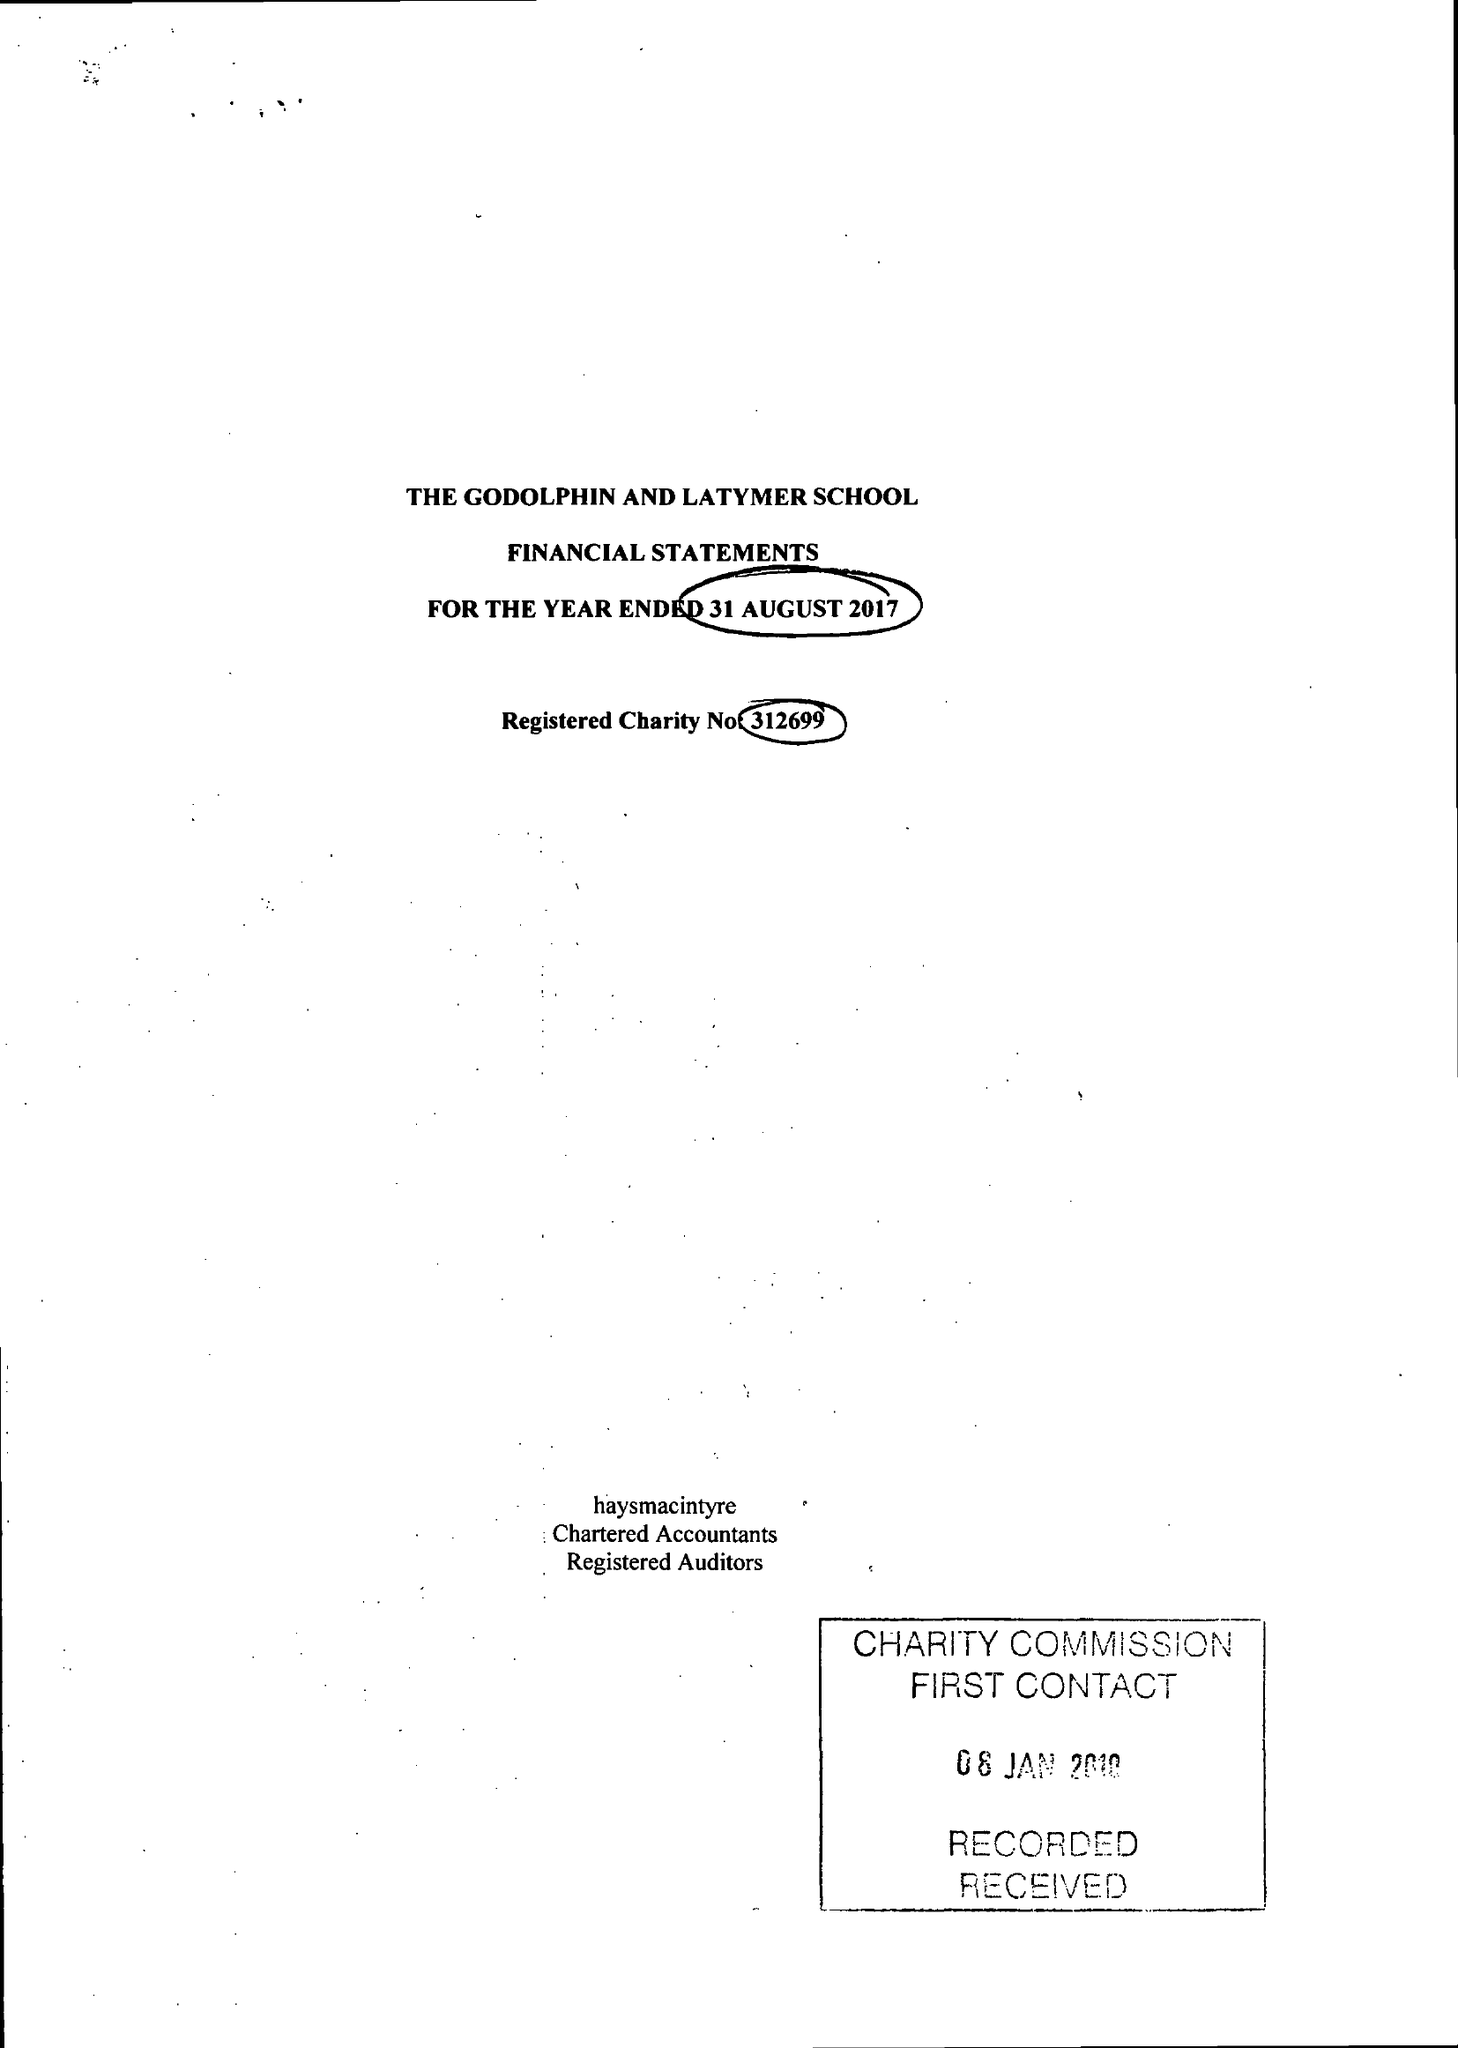What is the value for the report_date?
Answer the question using a single word or phrase. 2017-08-31 